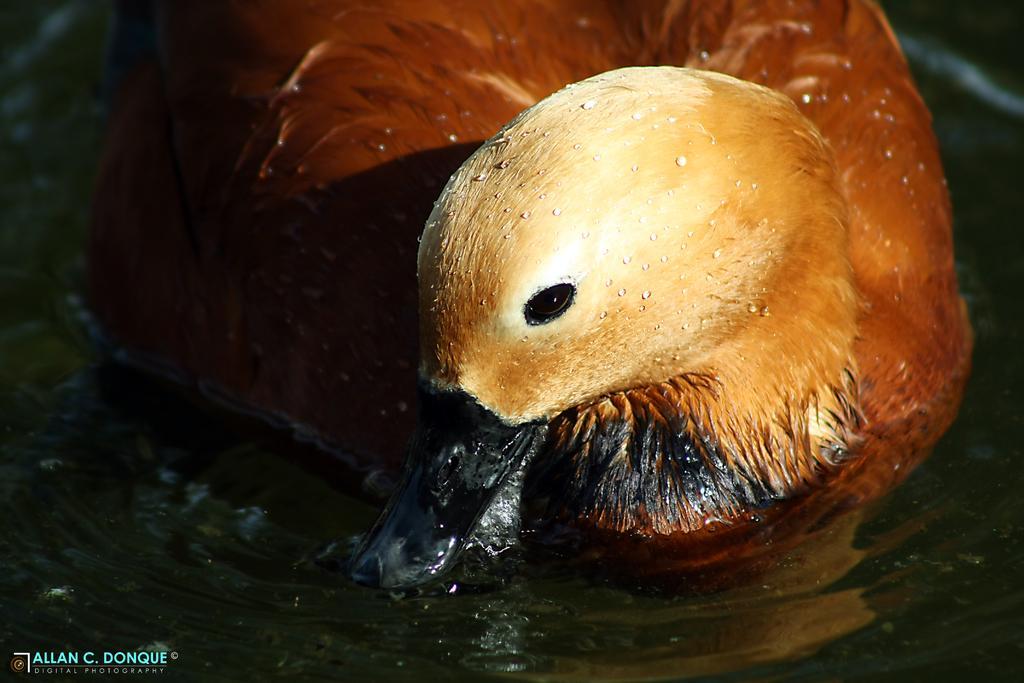Describe this image in one or two sentences. In the foreground of this image, there is a duck on the water. 